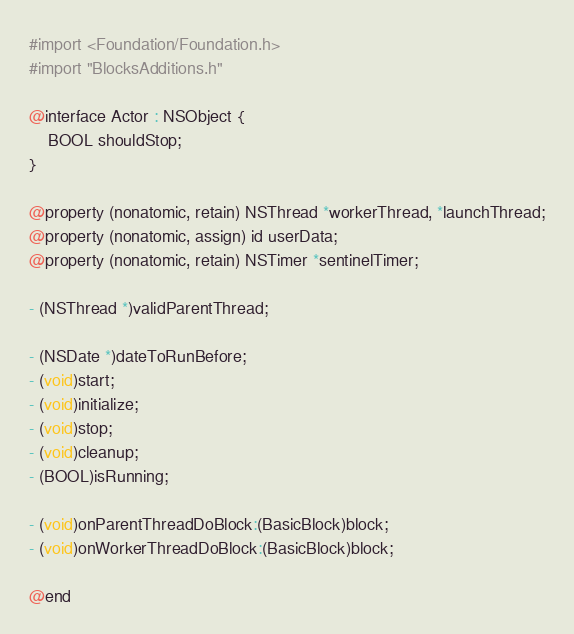<code> <loc_0><loc_0><loc_500><loc_500><_C_>#import <Foundation/Foundation.h>
#import "BlocksAdditions.h"

@interface Actor : NSObject {
    BOOL shouldStop;
}

@property (nonatomic, retain) NSThread *workerThread, *launchThread;
@property (nonatomic, assign) id userData;
@property (nonatomic, retain) NSTimer *sentinelTimer;

- (NSThread *)validParentThread;

- (NSDate *)dateToRunBefore;
- (void)start;
- (void)initialize;
- (void)stop;
- (void)cleanup;
- (BOOL)isRunning;

- (void)onParentThreadDoBlock:(BasicBlock)block;
- (void)onWorkerThreadDoBlock:(BasicBlock)block;

@end

</code> 